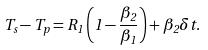Convert formula to latex. <formula><loc_0><loc_0><loc_500><loc_500>T _ { s } - T _ { p } = R _ { 1 } \left ( 1 - \frac { \beta _ { 2 } } { \beta _ { 1 } } \right ) + \beta _ { 2 } \delta t .</formula> 